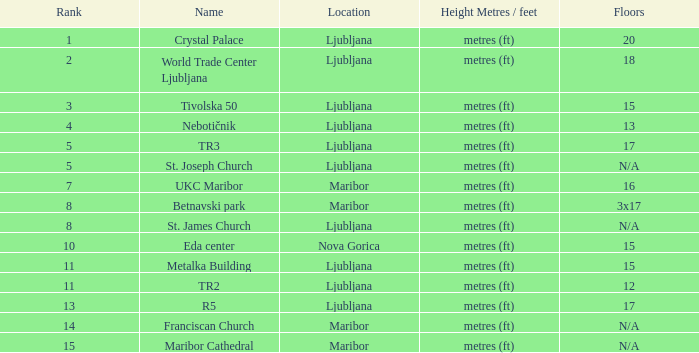Which Rank is the lowest one that has a Name of maribor cathedral? 15.0. 